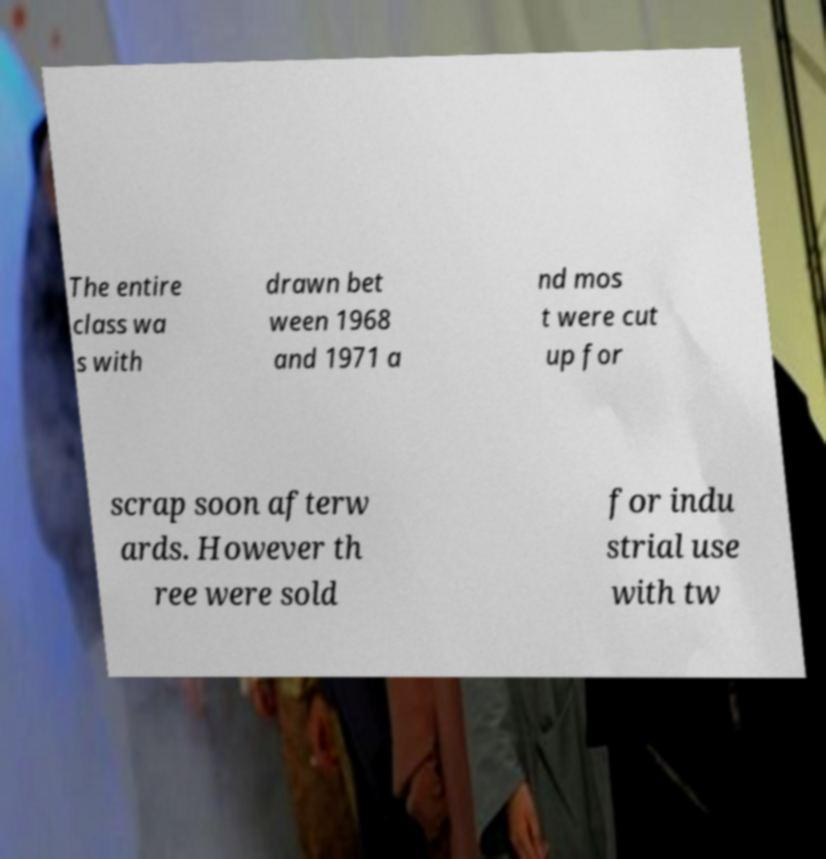There's text embedded in this image that I need extracted. Can you transcribe it verbatim? The entire class wa s with drawn bet ween 1968 and 1971 a nd mos t were cut up for scrap soon afterw ards. However th ree were sold for indu strial use with tw 